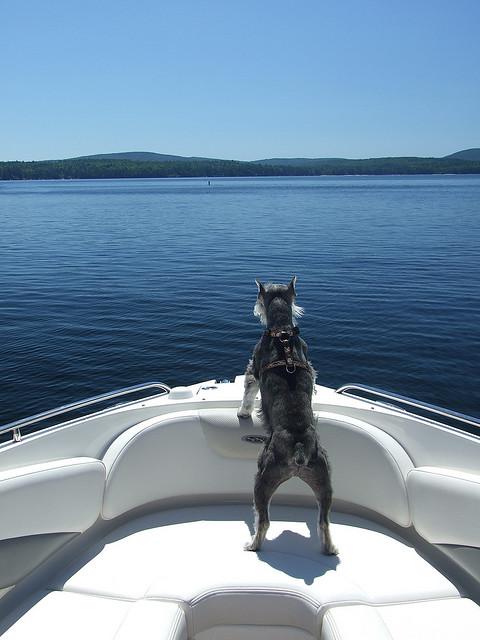Can we see the animal's owner?
Give a very brief answer. No. Is someone amused by this animal?
Write a very short answer. Yes. What is the black dog doing?
Keep it brief. Looking at water. 